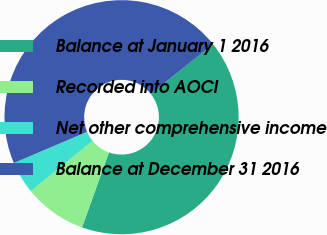<chart> <loc_0><loc_0><loc_500><loc_500><pie_chart><fcel>Balance at January 1 2016<fcel>Recorded into AOCI<fcel>Net other comprehensive income<fcel>Balance at December 31 2016<nl><fcel>41.19%<fcel>8.62%<fcel>4.5%<fcel>45.69%<nl></chart> 